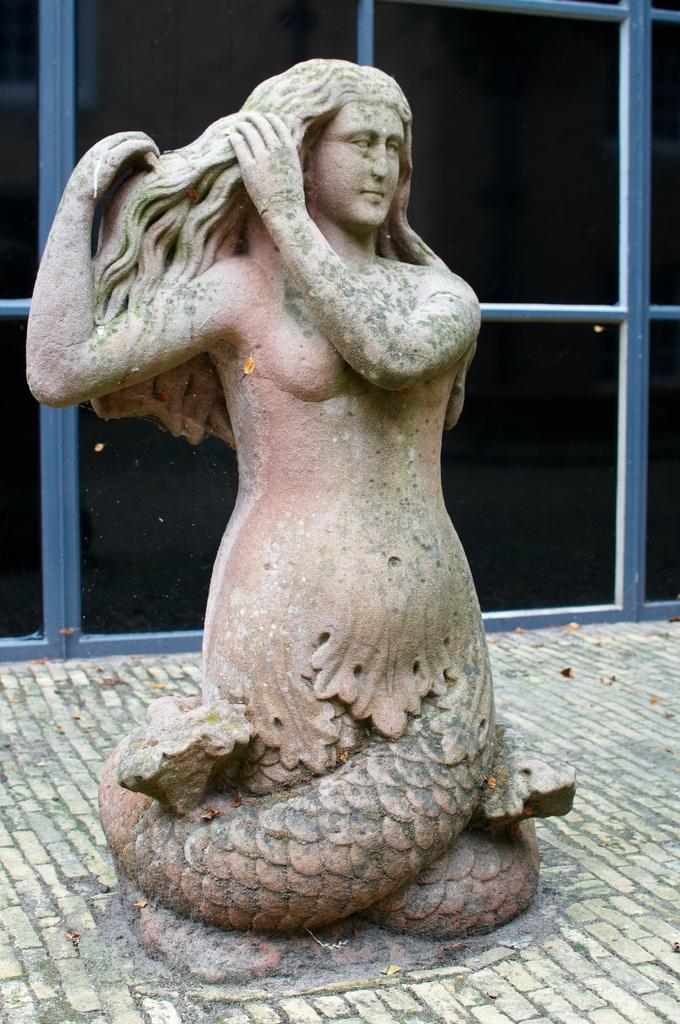Where was the image most likely taken? The image was likely taken indoors. What is the main subject of the image? There is a sculpture of a person in the center of the image. What can be seen in the background of the image? Metal rods and the pavement are visible in the background of the image. What type of sock is the person wearing in the image? There is no person present in the image, only a sculpture of a person. Therefore, it is not possible to determine what type of sock the person might be wearing. 